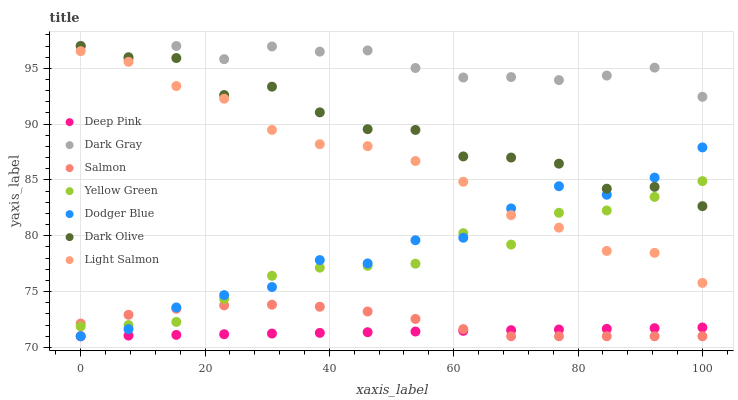Does Deep Pink have the minimum area under the curve?
Answer yes or no. Yes. Does Dark Gray have the maximum area under the curve?
Answer yes or no. Yes. Does Yellow Green have the minimum area under the curve?
Answer yes or no. No. Does Yellow Green have the maximum area under the curve?
Answer yes or no. No. Is Deep Pink the smoothest?
Answer yes or no. Yes. Is Dark Olive the roughest?
Answer yes or no. Yes. Is Yellow Green the smoothest?
Answer yes or no. No. Is Yellow Green the roughest?
Answer yes or no. No. Does Deep Pink have the lowest value?
Answer yes or no. Yes. Does Yellow Green have the lowest value?
Answer yes or no. No. Does Dark Gray have the highest value?
Answer yes or no. Yes. Does Yellow Green have the highest value?
Answer yes or no. No. Is Salmon less than Light Salmon?
Answer yes or no. Yes. Is Light Salmon greater than Deep Pink?
Answer yes or no. Yes. Does Yellow Green intersect Light Salmon?
Answer yes or no. Yes. Is Yellow Green less than Light Salmon?
Answer yes or no. No. Is Yellow Green greater than Light Salmon?
Answer yes or no. No. Does Salmon intersect Light Salmon?
Answer yes or no. No. 